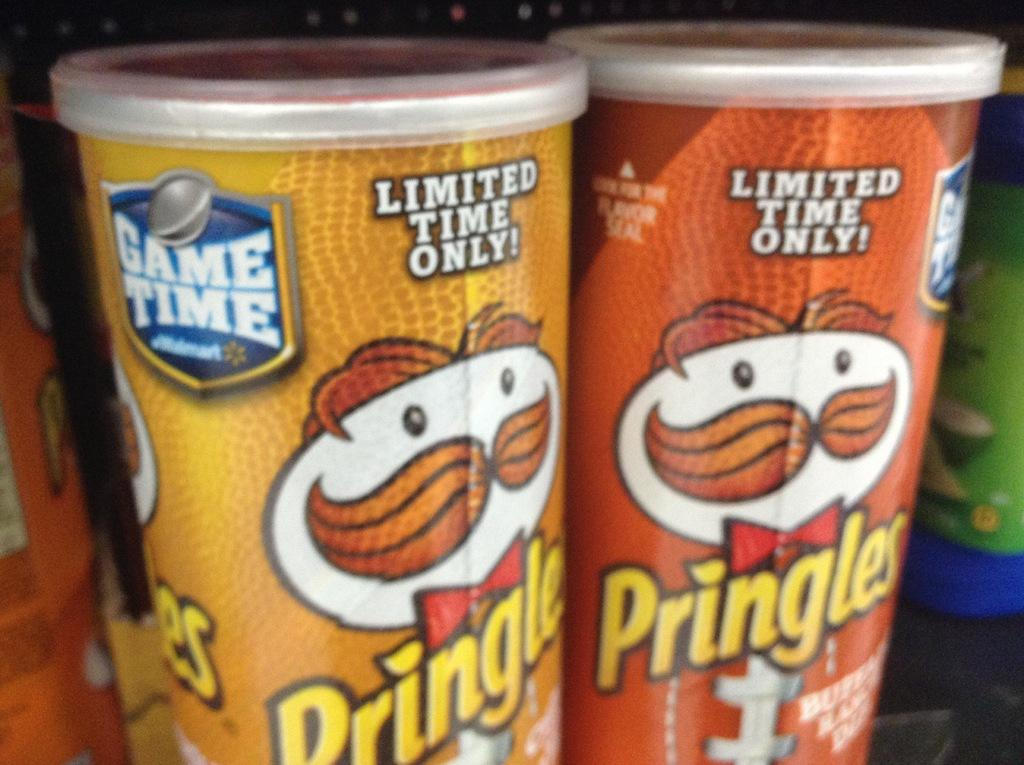<image>
Render a clear and concise summary of the photo. Two cans one is Pringles in a yellow can and one is Pringles in an orange can both are limited time only! 